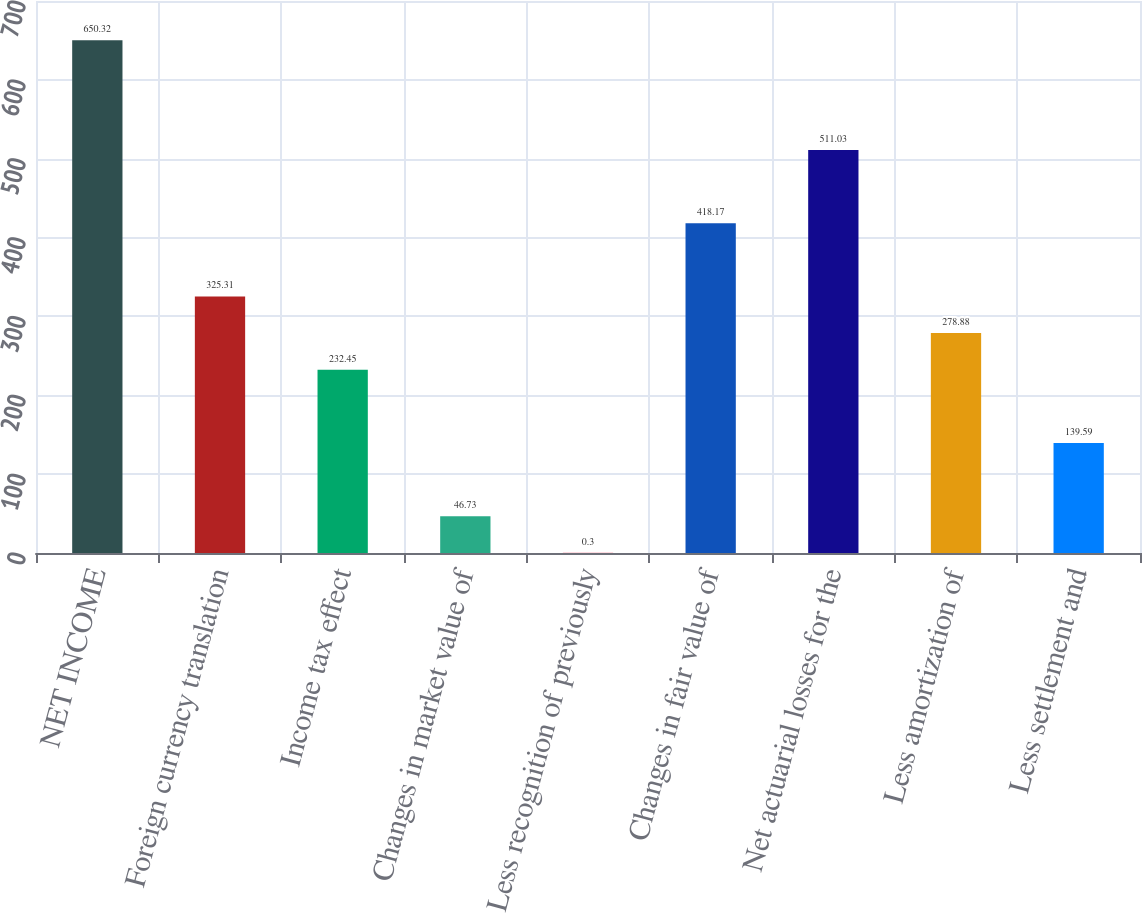<chart> <loc_0><loc_0><loc_500><loc_500><bar_chart><fcel>NET INCOME<fcel>Foreign currency translation<fcel>Income tax effect<fcel>Changes in market value of<fcel>Less recognition of previously<fcel>Changes in fair value of<fcel>Net actuarial losses for the<fcel>Less amortization of<fcel>Less settlement and<nl><fcel>650.32<fcel>325.31<fcel>232.45<fcel>46.73<fcel>0.3<fcel>418.17<fcel>511.03<fcel>278.88<fcel>139.59<nl></chart> 